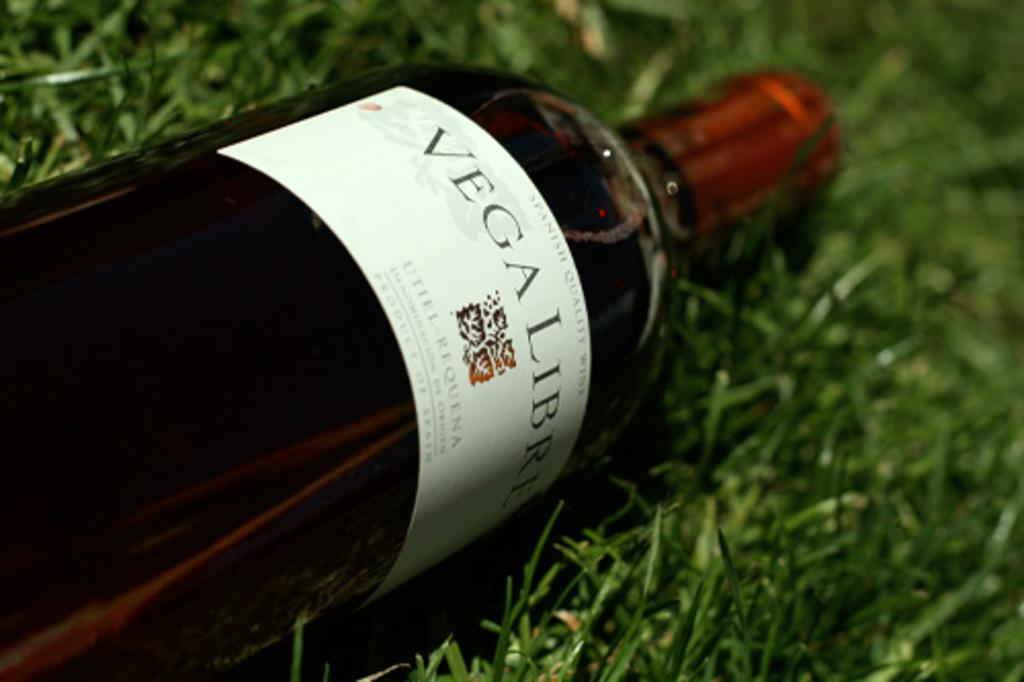<image>
Give a short and clear explanation of the subsequent image. the word Vegaligri that is on a bottle 